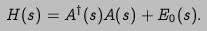Convert formula to latex. <formula><loc_0><loc_0><loc_500><loc_500>H ( s ) = A ^ { \dagger } ( s ) A ( s ) + E _ { 0 } ( s ) .</formula> 